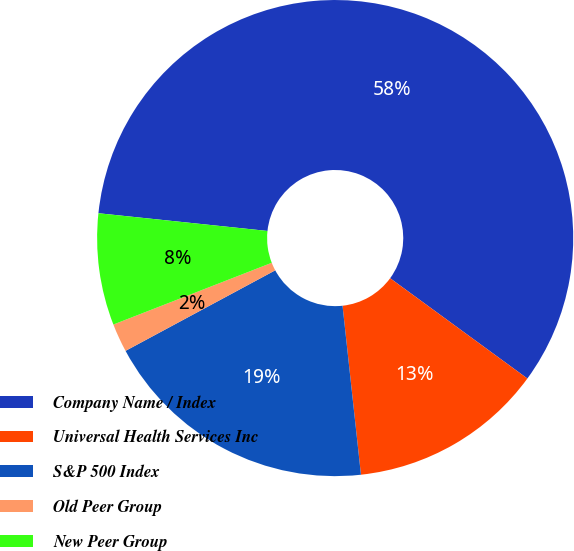Convert chart. <chart><loc_0><loc_0><loc_500><loc_500><pie_chart><fcel>Company Name / Index<fcel>Universal Health Services Inc<fcel>S&P 500 Index<fcel>Old Peer Group<fcel>New Peer Group<nl><fcel>58.38%<fcel>13.23%<fcel>18.87%<fcel>1.94%<fcel>7.58%<nl></chart> 